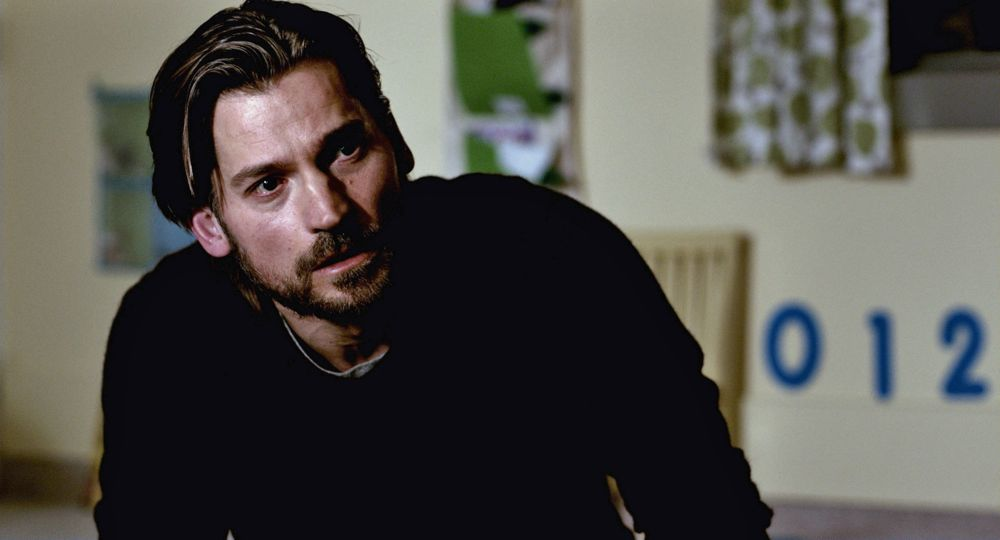Describe the emotions conveyed by the man in the image. The man in the image appears to convey a sense of contemplation and seriousness. His eyes are focused slightly off to the side, indicating deep thought or a meaningful conversation occurring just out of frame. The neutral yet somber lighting adds to the introspective mood, and his slightly furrowed brow suggests that the topic of his contemplation might be complex or troubling. What could be the possible context of this scene? The context of this scene could be a moment of reflection or a serious discussion. The man's focus and the lack of other distractions around him imply an environment where important matters are being considered. The numbers '012' on the wall could indicate a classroom, nursery, or some other educational or care facility. This setting may hint at the man contemplating a significant decision or discussing an important issue related to education or the future of his child (if he has any). What could the numbers '012' on the wall signify in this context? The numbers '012' on the wall could signify various things. In a nursery or early education context, they might be used as part of teaching children to recognize and learn numbers. These numbers could also be part of a room numbering system in an institution or be related to a thematic element within the scene, such as a date, code, or significant number sequence relevant to the storyline or the man’s contemplative state. 